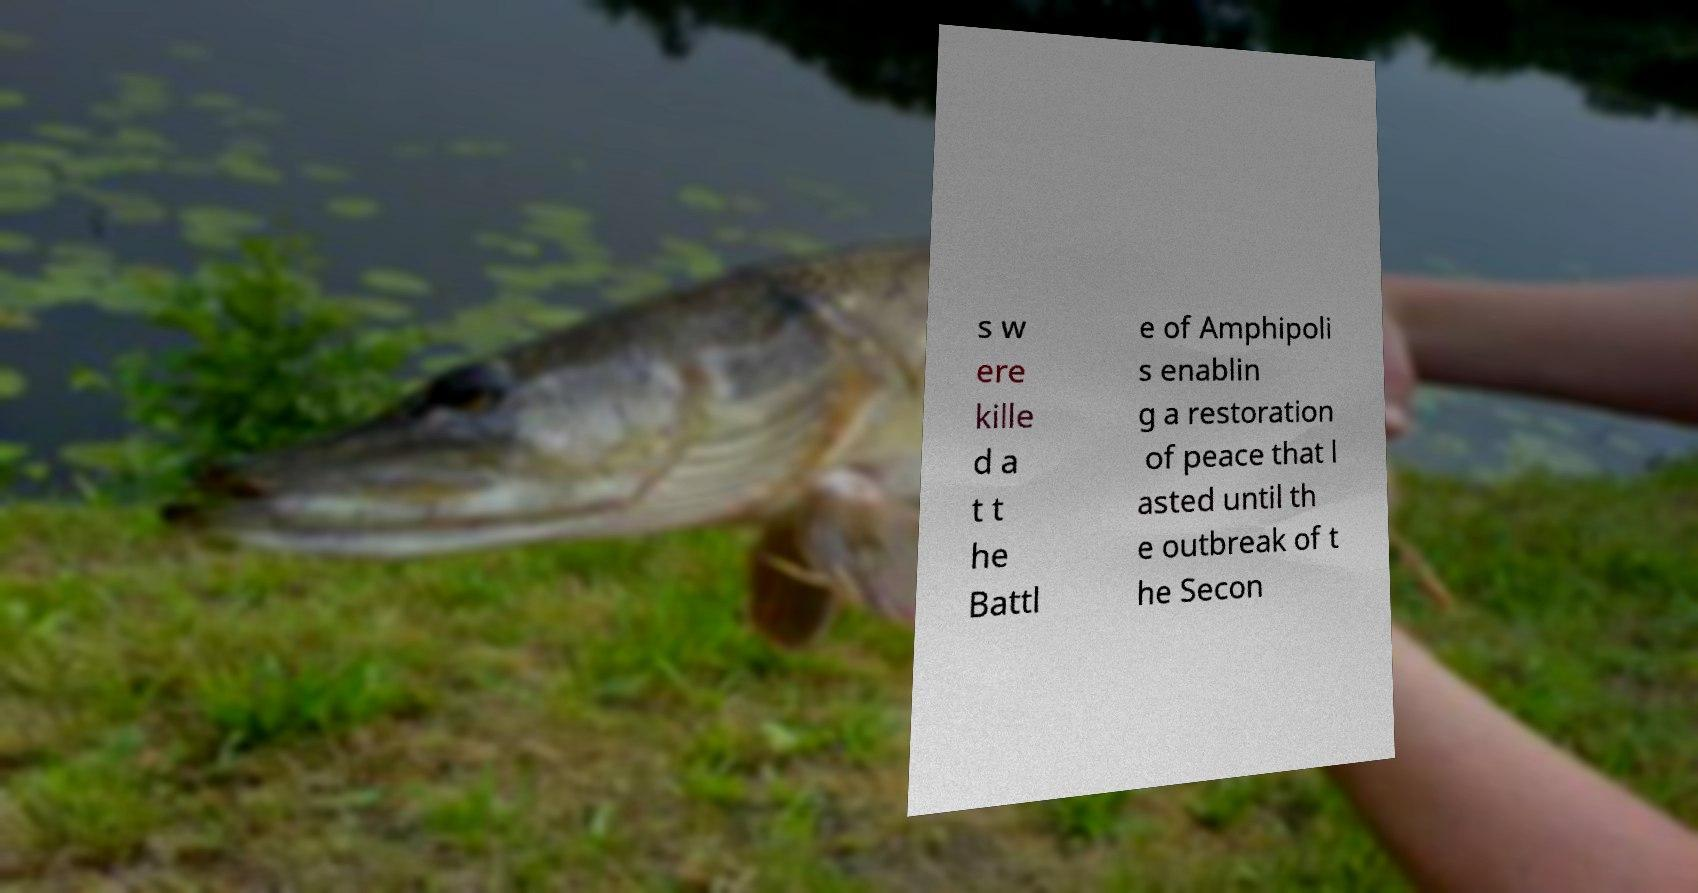What messages or text are displayed in this image? I need them in a readable, typed format. s w ere kille d a t t he Battl e of Amphipoli s enablin g a restoration of peace that l asted until th e outbreak of t he Secon 